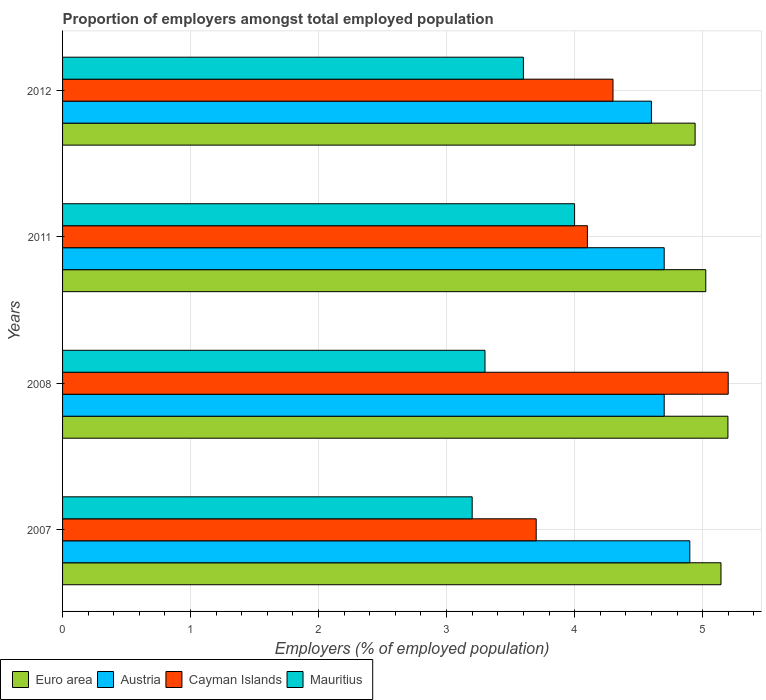How many different coloured bars are there?
Keep it short and to the point. 4. How many bars are there on the 4th tick from the top?
Provide a succinct answer. 4. How many bars are there on the 1st tick from the bottom?
Provide a short and direct response. 4. What is the label of the 2nd group of bars from the top?
Your answer should be compact. 2011. In how many cases, is the number of bars for a given year not equal to the number of legend labels?
Offer a very short reply. 0. What is the proportion of employers in Austria in 2008?
Provide a short and direct response. 4.7. Across all years, what is the maximum proportion of employers in Euro area?
Your answer should be compact. 5.2. Across all years, what is the minimum proportion of employers in Cayman Islands?
Offer a very short reply. 3.7. What is the total proportion of employers in Euro area in the graph?
Your answer should be very brief. 20.31. What is the difference between the proportion of employers in Euro area in 2007 and that in 2011?
Make the answer very short. 0.12. What is the difference between the proportion of employers in Austria in 2007 and the proportion of employers in Mauritius in 2012?
Keep it short and to the point. 1.3. What is the average proportion of employers in Austria per year?
Provide a short and direct response. 4.72. In the year 2008, what is the difference between the proportion of employers in Mauritius and proportion of employers in Cayman Islands?
Ensure brevity in your answer.  -1.9. In how many years, is the proportion of employers in Euro area greater than 4 %?
Ensure brevity in your answer.  4. What is the ratio of the proportion of employers in Mauritius in 2007 to that in 2012?
Your response must be concise. 0.89. What is the difference between the highest and the second highest proportion of employers in Cayman Islands?
Offer a very short reply. 0.9. What is the difference between the highest and the lowest proportion of employers in Cayman Islands?
Your answer should be very brief. 1.5. In how many years, is the proportion of employers in Cayman Islands greater than the average proportion of employers in Cayman Islands taken over all years?
Provide a short and direct response. 1. Is it the case that in every year, the sum of the proportion of employers in Cayman Islands and proportion of employers in Mauritius is greater than the sum of proportion of employers in Euro area and proportion of employers in Austria?
Your response must be concise. No. What does the 3rd bar from the bottom in 2011 represents?
Provide a succinct answer. Cayman Islands. How many years are there in the graph?
Your answer should be compact. 4. Does the graph contain any zero values?
Your response must be concise. No. How many legend labels are there?
Keep it short and to the point. 4. What is the title of the graph?
Your answer should be compact. Proportion of employers amongst total employed population. Does "Micronesia" appear as one of the legend labels in the graph?
Give a very brief answer. No. What is the label or title of the X-axis?
Make the answer very short. Employers (% of employed population). What is the label or title of the Y-axis?
Offer a very short reply. Years. What is the Employers (% of employed population) in Euro area in 2007?
Your answer should be compact. 5.14. What is the Employers (% of employed population) in Austria in 2007?
Make the answer very short. 4.9. What is the Employers (% of employed population) in Cayman Islands in 2007?
Your answer should be very brief. 3.7. What is the Employers (% of employed population) in Mauritius in 2007?
Your answer should be compact. 3.2. What is the Employers (% of employed population) in Euro area in 2008?
Offer a terse response. 5.2. What is the Employers (% of employed population) of Austria in 2008?
Your answer should be very brief. 4.7. What is the Employers (% of employed population) of Cayman Islands in 2008?
Keep it short and to the point. 5.2. What is the Employers (% of employed population) in Mauritius in 2008?
Give a very brief answer. 3.3. What is the Employers (% of employed population) of Euro area in 2011?
Provide a succinct answer. 5.02. What is the Employers (% of employed population) of Austria in 2011?
Your response must be concise. 4.7. What is the Employers (% of employed population) of Cayman Islands in 2011?
Keep it short and to the point. 4.1. What is the Employers (% of employed population) in Mauritius in 2011?
Ensure brevity in your answer.  4. What is the Employers (% of employed population) in Euro area in 2012?
Your response must be concise. 4.94. What is the Employers (% of employed population) in Austria in 2012?
Provide a succinct answer. 4.6. What is the Employers (% of employed population) in Cayman Islands in 2012?
Your response must be concise. 4.3. What is the Employers (% of employed population) in Mauritius in 2012?
Give a very brief answer. 3.6. Across all years, what is the maximum Employers (% of employed population) of Euro area?
Offer a terse response. 5.2. Across all years, what is the maximum Employers (% of employed population) of Austria?
Give a very brief answer. 4.9. Across all years, what is the maximum Employers (% of employed population) in Cayman Islands?
Keep it short and to the point. 5.2. Across all years, what is the minimum Employers (% of employed population) in Euro area?
Provide a short and direct response. 4.94. Across all years, what is the minimum Employers (% of employed population) of Austria?
Your response must be concise. 4.6. Across all years, what is the minimum Employers (% of employed population) of Cayman Islands?
Ensure brevity in your answer.  3.7. Across all years, what is the minimum Employers (% of employed population) in Mauritius?
Your response must be concise. 3.2. What is the total Employers (% of employed population) of Euro area in the graph?
Provide a succinct answer. 20.31. What is the total Employers (% of employed population) in Cayman Islands in the graph?
Provide a succinct answer. 17.3. What is the difference between the Employers (% of employed population) of Euro area in 2007 and that in 2008?
Offer a terse response. -0.05. What is the difference between the Employers (% of employed population) of Mauritius in 2007 and that in 2008?
Provide a succinct answer. -0.1. What is the difference between the Employers (% of employed population) of Euro area in 2007 and that in 2011?
Your answer should be very brief. 0.12. What is the difference between the Employers (% of employed population) in Cayman Islands in 2007 and that in 2011?
Offer a very short reply. -0.4. What is the difference between the Employers (% of employed population) of Euro area in 2007 and that in 2012?
Give a very brief answer. 0.2. What is the difference between the Employers (% of employed population) of Cayman Islands in 2007 and that in 2012?
Give a very brief answer. -0.6. What is the difference between the Employers (% of employed population) in Mauritius in 2007 and that in 2012?
Give a very brief answer. -0.4. What is the difference between the Employers (% of employed population) in Euro area in 2008 and that in 2011?
Make the answer very short. 0.17. What is the difference between the Employers (% of employed population) of Cayman Islands in 2008 and that in 2011?
Provide a succinct answer. 1.1. What is the difference between the Employers (% of employed population) of Euro area in 2008 and that in 2012?
Provide a succinct answer. 0.26. What is the difference between the Employers (% of employed population) of Austria in 2008 and that in 2012?
Give a very brief answer. 0.1. What is the difference between the Employers (% of employed population) of Euro area in 2011 and that in 2012?
Provide a succinct answer. 0.08. What is the difference between the Employers (% of employed population) in Cayman Islands in 2011 and that in 2012?
Offer a terse response. -0.2. What is the difference between the Employers (% of employed population) of Euro area in 2007 and the Employers (% of employed population) of Austria in 2008?
Provide a succinct answer. 0.44. What is the difference between the Employers (% of employed population) of Euro area in 2007 and the Employers (% of employed population) of Cayman Islands in 2008?
Your answer should be very brief. -0.06. What is the difference between the Employers (% of employed population) in Euro area in 2007 and the Employers (% of employed population) in Mauritius in 2008?
Provide a short and direct response. 1.84. What is the difference between the Employers (% of employed population) of Austria in 2007 and the Employers (% of employed population) of Cayman Islands in 2008?
Your answer should be very brief. -0.3. What is the difference between the Employers (% of employed population) of Austria in 2007 and the Employers (% of employed population) of Mauritius in 2008?
Your answer should be very brief. 1.6. What is the difference between the Employers (% of employed population) of Euro area in 2007 and the Employers (% of employed population) of Austria in 2011?
Ensure brevity in your answer.  0.44. What is the difference between the Employers (% of employed population) of Euro area in 2007 and the Employers (% of employed population) of Cayman Islands in 2011?
Offer a very short reply. 1.04. What is the difference between the Employers (% of employed population) of Euro area in 2007 and the Employers (% of employed population) of Mauritius in 2011?
Your answer should be compact. 1.14. What is the difference between the Employers (% of employed population) of Cayman Islands in 2007 and the Employers (% of employed population) of Mauritius in 2011?
Provide a short and direct response. -0.3. What is the difference between the Employers (% of employed population) of Euro area in 2007 and the Employers (% of employed population) of Austria in 2012?
Give a very brief answer. 0.54. What is the difference between the Employers (% of employed population) of Euro area in 2007 and the Employers (% of employed population) of Cayman Islands in 2012?
Your answer should be compact. 0.84. What is the difference between the Employers (% of employed population) in Euro area in 2007 and the Employers (% of employed population) in Mauritius in 2012?
Offer a very short reply. 1.54. What is the difference between the Employers (% of employed population) in Austria in 2007 and the Employers (% of employed population) in Cayman Islands in 2012?
Offer a very short reply. 0.6. What is the difference between the Employers (% of employed population) in Euro area in 2008 and the Employers (% of employed population) in Austria in 2011?
Provide a succinct answer. 0.5. What is the difference between the Employers (% of employed population) in Euro area in 2008 and the Employers (% of employed population) in Cayman Islands in 2011?
Offer a very short reply. 1.1. What is the difference between the Employers (% of employed population) in Euro area in 2008 and the Employers (% of employed population) in Mauritius in 2011?
Your response must be concise. 1.2. What is the difference between the Employers (% of employed population) of Euro area in 2008 and the Employers (% of employed population) of Austria in 2012?
Offer a very short reply. 0.6. What is the difference between the Employers (% of employed population) in Euro area in 2008 and the Employers (% of employed population) in Cayman Islands in 2012?
Provide a succinct answer. 0.9. What is the difference between the Employers (% of employed population) in Euro area in 2008 and the Employers (% of employed population) in Mauritius in 2012?
Provide a succinct answer. 1.6. What is the difference between the Employers (% of employed population) of Austria in 2008 and the Employers (% of employed population) of Cayman Islands in 2012?
Offer a very short reply. 0.4. What is the difference between the Employers (% of employed population) of Austria in 2008 and the Employers (% of employed population) of Mauritius in 2012?
Your response must be concise. 1.1. What is the difference between the Employers (% of employed population) in Cayman Islands in 2008 and the Employers (% of employed population) in Mauritius in 2012?
Offer a very short reply. 1.6. What is the difference between the Employers (% of employed population) in Euro area in 2011 and the Employers (% of employed population) in Austria in 2012?
Your answer should be compact. 0.42. What is the difference between the Employers (% of employed population) in Euro area in 2011 and the Employers (% of employed population) in Cayman Islands in 2012?
Your response must be concise. 0.72. What is the difference between the Employers (% of employed population) of Euro area in 2011 and the Employers (% of employed population) of Mauritius in 2012?
Your response must be concise. 1.42. What is the difference between the Employers (% of employed population) of Austria in 2011 and the Employers (% of employed population) of Cayman Islands in 2012?
Make the answer very short. 0.4. What is the difference between the Employers (% of employed population) in Cayman Islands in 2011 and the Employers (% of employed population) in Mauritius in 2012?
Your answer should be very brief. 0.5. What is the average Employers (% of employed population) of Euro area per year?
Make the answer very short. 5.08. What is the average Employers (% of employed population) of Austria per year?
Keep it short and to the point. 4.72. What is the average Employers (% of employed population) in Cayman Islands per year?
Provide a succinct answer. 4.33. What is the average Employers (% of employed population) in Mauritius per year?
Make the answer very short. 3.52. In the year 2007, what is the difference between the Employers (% of employed population) of Euro area and Employers (% of employed population) of Austria?
Provide a succinct answer. 0.24. In the year 2007, what is the difference between the Employers (% of employed population) of Euro area and Employers (% of employed population) of Cayman Islands?
Your answer should be compact. 1.44. In the year 2007, what is the difference between the Employers (% of employed population) of Euro area and Employers (% of employed population) of Mauritius?
Provide a short and direct response. 1.94. In the year 2007, what is the difference between the Employers (% of employed population) in Austria and Employers (% of employed population) in Cayman Islands?
Your response must be concise. 1.2. In the year 2008, what is the difference between the Employers (% of employed population) in Euro area and Employers (% of employed population) in Austria?
Offer a terse response. 0.5. In the year 2008, what is the difference between the Employers (% of employed population) in Euro area and Employers (% of employed population) in Cayman Islands?
Keep it short and to the point. -0. In the year 2008, what is the difference between the Employers (% of employed population) in Euro area and Employers (% of employed population) in Mauritius?
Your response must be concise. 1.9. In the year 2008, what is the difference between the Employers (% of employed population) of Austria and Employers (% of employed population) of Mauritius?
Your response must be concise. 1.4. In the year 2011, what is the difference between the Employers (% of employed population) in Euro area and Employers (% of employed population) in Austria?
Offer a terse response. 0.32. In the year 2011, what is the difference between the Employers (% of employed population) of Euro area and Employers (% of employed population) of Cayman Islands?
Your answer should be compact. 0.92. In the year 2011, what is the difference between the Employers (% of employed population) in Euro area and Employers (% of employed population) in Mauritius?
Make the answer very short. 1.02. In the year 2011, what is the difference between the Employers (% of employed population) in Cayman Islands and Employers (% of employed population) in Mauritius?
Ensure brevity in your answer.  0.1. In the year 2012, what is the difference between the Employers (% of employed population) of Euro area and Employers (% of employed population) of Austria?
Your answer should be compact. 0.34. In the year 2012, what is the difference between the Employers (% of employed population) in Euro area and Employers (% of employed population) in Cayman Islands?
Your answer should be very brief. 0.64. In the year 2012, what is the difference between the Employers (% of employed population) in Euro area and Employers (% of employed population) in Mauritius?
Your response must be concise. 1.34. In the year 2012, what is the difference between the Employers (% of employed population) in Austria and Employers (% of employed population) in Cayman Islands?
Make the answer very short. 0.3. In the year 2012, what is the difference between the Employers (% of employed population) in Cayman Islands and Employers (% of employed population) in Mauritius?
Keep it short and to the point. 0.7. What is the ratio of the Employers (% of employed population) in Austria in 2007 to that in 2008?
Keep it short and to the point. 1.04. What is the ratio of the Employers (% of employed population) of Cayman Islands in 2007 to that in 2008?
Give a very brief answer. 0.71. What is the ratio of the Employers (% of employed population) of Mauritius in 2007 to that in 2008?
Give a very brief answer. 0.97. What is the ratio of the Employers (% of employed population) in Euro area in 2007 to that in 2011?
Keep it short and to the point. 1.02. What is the ratio of the Employers (% of employed population) of Austria in 2007 to that in 2011?
Provide a short and direct response. 1.04. What is the ratio of the Employers (% of employed population) in Cayman Islands in 2007 to that in 2011?
Your answer should be very brief. 0.9. What is the ratio of the Employers (% of employed population) of Euro area in 2007 to that in 2012?
Offer a very short reply. 1.04. What is the ratio of the Employers (% of employed population) in Austria in 2007 to that in 2012?
Provide a succinct answer. 1.07. What is the ratio of the Employers (% of employed population) in Cayman Islands in 2007 to that in 2012?
Make the answer very short. 0.86. What is the ratio of the Employers (% of employed population) in Euro area in 2008 to that in 2011?
Make the answer very short. 1.03. What is the ratio of the Employers (% of employed population) in Austria in 2008 to that in 2011?
Offer a terse response. 1. What is the ratio of the Employers (% of employed population) of Cayman Islands in 2008 to that in 2011?
Offer a terse response. 1.27. What is the ratio of the Employers (% of employed population) of Mauritius in 2008 to that in 2011?
Provide a succinct answer. 0.82. What is the ratio of the Employers (% of employed population) in Euro area in 2008 to that in 2012?
Your answer should be compact. 1.05. What is the ratio of the Employers (% of employed population) in Austria in 2008 to that in 2012?
Make the answer very short. 1.02. What is the ratio of the Employers (% of employed population) of Cayman Islands in 2008 to that in 2012?
Offer a terse response. 1.21. What is the ratio of the Employers (% of employed population) in Euro area in 2011 to that in 2012?
Offer a terse response. 1.02. What is the ratio of the Employers (% of employed population) in Austria in 2011 to that in 2012?
Ensure brevity in your answer.  1.02. What is the ratio of the Employers (% of employed population) of Cayman Islands in 2011 to that in 2012?
Make the answer very short. 0.95. What is the difference between the highest and the second highest Employers (% of employed population) in Euro area?
Your response must be concise. 0.05. What is the difference between the highest and the second highest Employers (% of employed population) in Austria?
Your answer should be compact. 0.2. What is the difference between the highest and the lowest Employers (% of employed population) of Euro area?
Offer a very short reply. 0.26. What is the difference between the highest and the lowest Employers (% of employed population) in Austria?
Provide a succinct answer. 0.3. What is the difference between the highest and the lowest Employers (% of employed population) in Cayman Islands?
Provide a succinct answer. 1.5. 